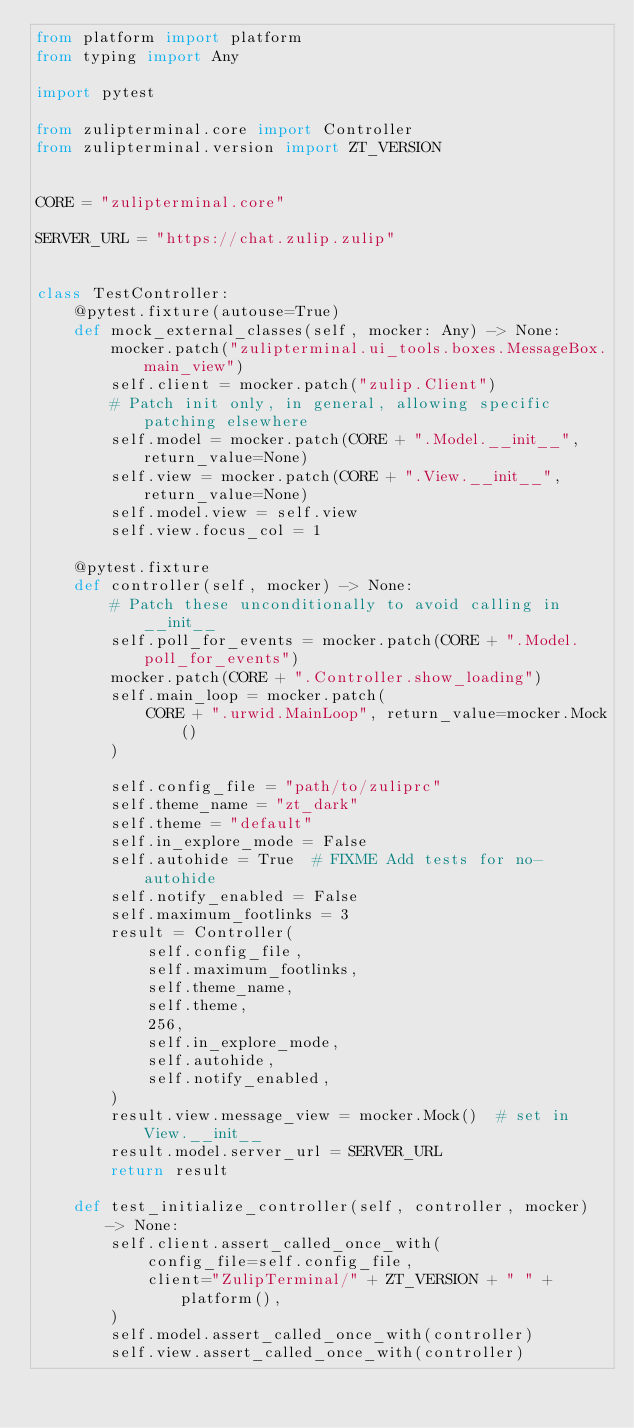<code> <loc_0><loc_0><loc_500><loc_500><_Python_>from platform import platform
from typing import Any

import pytest

from zulipterminal.core import Controller
from zulipterminal.version import ZT_VERSION


CORE = "zulipterminal.core"

SERVER_URL = "https://chat.zulip.zulip"


class TestController:
    @pytest.fixture(autouse=True)
    def mock_external_classes(self, mocker: Any) -> None:
        mocker.patch("zulipterminal.ui_tools.boxes.MessageBox.main_view")
        self.client = mocker.patch("zulip.Client")
        # Patch init only, in general, allowing specific patching elsewhere
        self.model = mocker.patch(CORE + ".Model.__init__", return_value=None)
        self.view = mocker.patch(CORE + ".View.__init__", return_value=None)
        self.model.view = self.view
        self.view.focus_col = 1

    @pytest.fixture
    def controller(self, mocker) -> None:
        # Patch these unconditionally to avoid calling in __init__
        self.poll_for_events = mocker.patch(CORE + ".Model.poll_for_events")
        mocker.patch(CORE + ".Controller.show_loading")
        self.main_loop = mocker.patch(
            CORE + ".urwid.MainLoop", return_value=mocker.Mock()
        )

        self.config_file = "path/to/zuliprc"
        self.theme_name = "zt_dark"
        self.theme = "default"
        self.in_explore_mode = False
        self.autohide = True  # FIXME Add tests for no-autohide
        self.notify_enabled = False
        self.maximum_footlinks = 3
        result = Controller(
            self.config_file,
            self.maximum_footlinks,
            self.theme_name,
            self.theme,
            256,
            self.in_explore_mode,
            self.autohide,
            self.notify_enabled,
        )
        result.view.message_view = mocker.Mock()  # set in View.__init__
        result.model.server_url = SERVER_URL
        return result

    def test_initialize_controller(self, controller, mocker) -> None:
        self.client.assert_called_once_with(
            config_file=self.config_file,
            client="ZulipTerminal/" + ZT_VERSION + " " + platform(),
        )
        self.model.assert_called_once_with(controller)
        self.view.assert_called_once_with(controller)</code> 